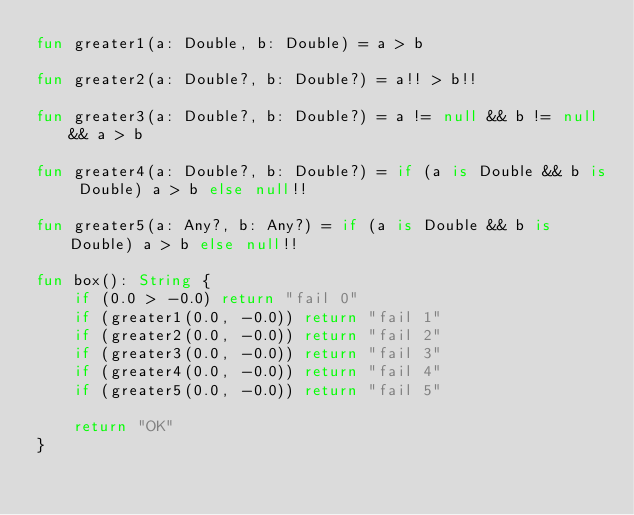Convert code to text. <code><loc_0><loc_0><loc_500><loc_500><_Kotlin_>fun greater1(a: Double, b: Double) = a > b

fun greater2(a: Double?, b: Double?) = a!! > b!!

fun greater3(a: Double?, b: Double?) = a != null && b != null && a > b

fun greater4(a: Double?, b: Double?) = if (a is Double && b is Double) a > b else null!!

fun greater5(a: Any?, b: Any?) = if (a is Double && b is Double) a > b else null!!

fun box(): String {
    if (0.0 > -0.0) return "fail 0"
    if (greater1(0.0, -0.0)) return "fail 1"
    if (greater2(0.0, -0.0)) return "fail 2"
    if (greater3(0.0, -0.0)) return "fail 3"
    if (greater4(0.0, -0.0)) return "fail 4"
    if (greater5(0.0, -0.0)) return "fail 5"

    return "OK"
}</code> 